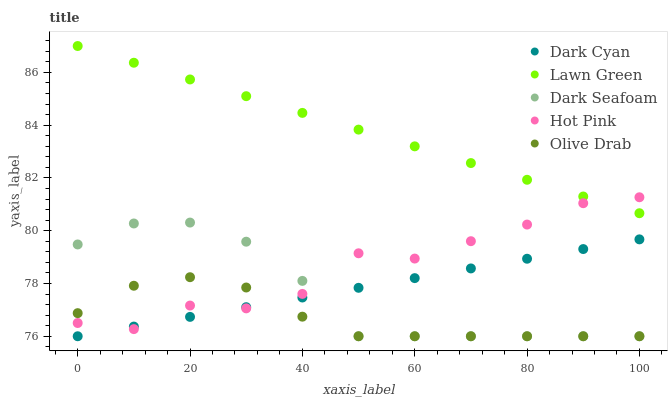Does Olive Drab have the minimum area under the curve?
Answer yes or no. Yes. Does Lawn Green have the maximum area under the curve?
Answer yes or no. Yes. Does Dark Seafoam have the minimum area under the curve?
Answer yes or no. No. Does Dark Seafoam have the maximum area under the curve?
Answer yes or no. No. Is Dark Cyan the smoothest?
Answer yes or no. Yes. Is Hot Pink the roughest?
Answer yes or no. Yes. Is Lawn Green the smoothest?
Answer yes or no. No. Is Lawn Green the roughest?
Answer yes or no. No. Does Dark Cyan have the lowest value?
Answer yes or no. Yes. Does Lawn Green have the lowest value?
Answer yes or no. No. Does Lawn Green have the highest value?
Answer yes or no. Yes. Does Dark Seafoam have the highest value?
Answer yes or no. No. Is Dark Seafoam less than Lawn Green?
Answer yes or no. Yes. Is Lawn Green greater than Dark Cyan?
Answer yes or no. Yes. Does Olive Drab intersect Dark Cyan?
Answer yes or no. Yes. Is Olive Drab less than Dark Cyan?
Answer yes or no. No. Is Olive Drab greater than Dark Cyan?
Answer yes or no. No. Does Dark Seafoam intersect Lawn Green?
Answer yes or no. No. 